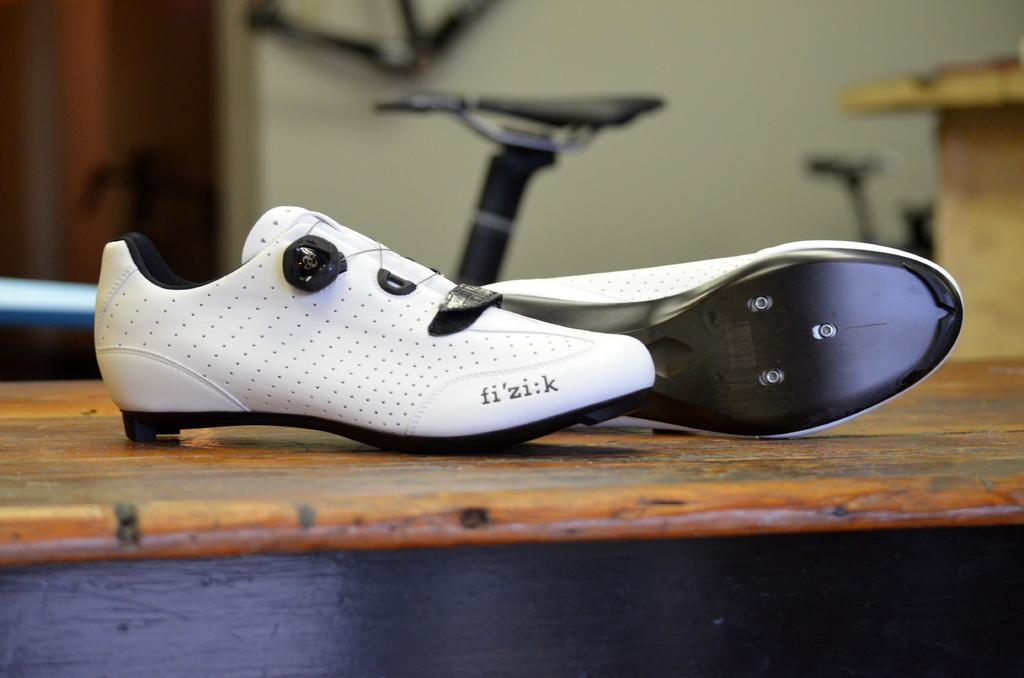What objects are placed on the wooden table in the image? There are two white shoes on a wooden table in the image. What mode of transportation can be seen in the image? There is a cycle visible in the image. What is located at the back side of the image? There is a wall at the back side of the image. What type of locket is hanging from the cycle in the image? There is no locket present in the image; it only features a cycle and a wall. How many arms are visible on the person riding the cycle in the image? There is no person riding the cycle in the image, so it is not possible to determine the number of arms. 